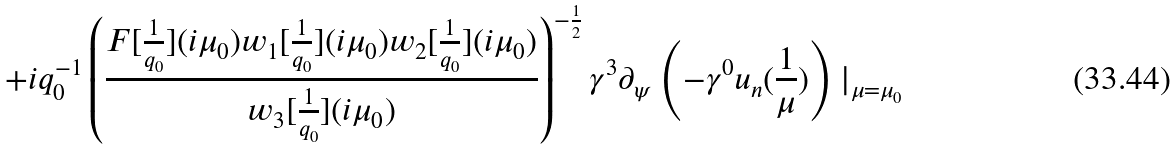Convert formula to latex. <formula><loc_0><loc_0><loc_500><loc_500>+ i q _ { 0 } ^ { - 1 } \left ( \frac { F [ \frac { 1 } { q _ { 0 } } ] ( i \mu _ { 0 } ) w _ { 1 } [ \frac { 1 } { q _ { 0 } } ] ( i \mu _ { 0 } ) w _ { 2 } [ \frac { 1 } { q _ { 0 } } ] ( i \mu _ { 0 } ) } { w _ { 3 } [ \frac { 1 } { q _ { 0 } } ] ( i \mu _ { 0 } ) } \right ) ^ { - \frac { 1 } { 2 } } \gamma ^ { 3 } \partial _ { \psi } \left ( - \gamma ^ { 0 } u _ { n } ( \frac { 1 } { \mu } ) \right ) | _ { \mu = \mu _ { 0 } }</formula> 